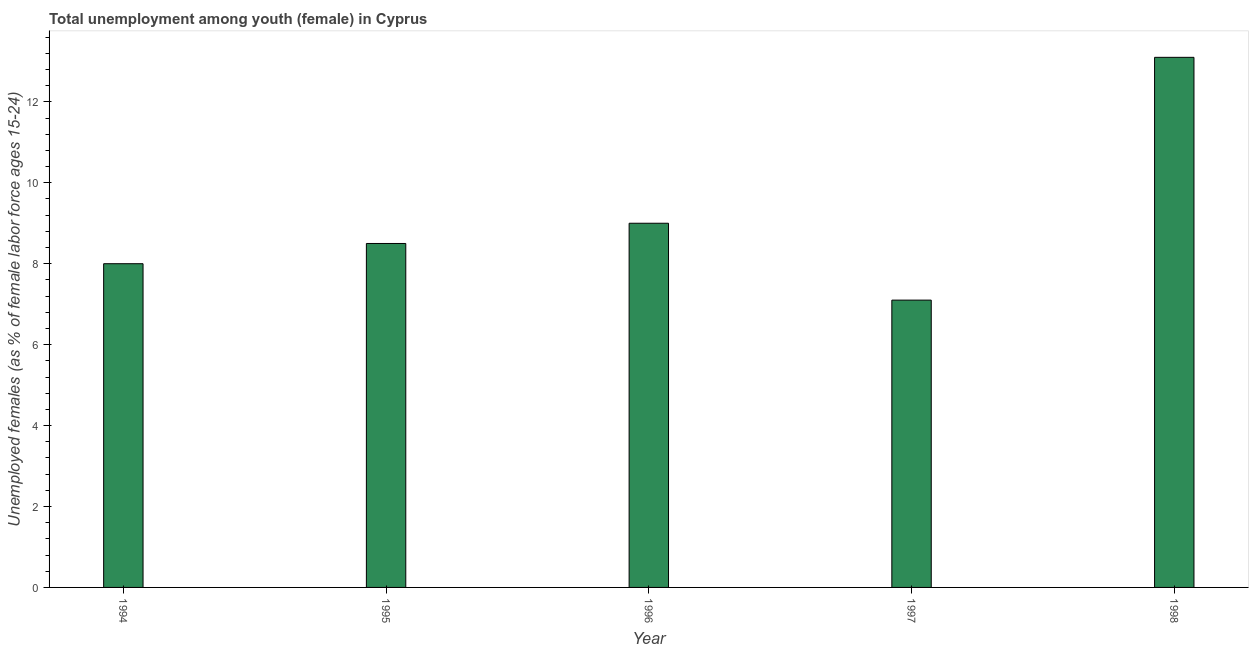Does the graph contain grids?
Offer a terse response. No. What is the title of the graph?
Your answer should be very brief. Total unemployment among youth (female) in Cyprus. What is the label or title of the Y-axis?
Provide a succinct answer. Unemployed females (as % of female labor force ages 15-24). What is the unemployed female youth population in 1997?
Keep it short and to the point. 7.1. Across all years, what is the maximum unemployed female youth population?
Your response must be concise. 13.1. Across all years, what is the minimum unemployed female youth population?
Your answer should be compact. 7.1. In which year was the unemployed female youth population maximum?
Your answer should be very brief. 1998. In which year was the unemployed female youth population minimum?
Your response must be concise. 1997. What is the sum of the unemployed female youth population?
Offer a very short reply. 45.7. What is the average unemployed female youth population per year?
Offer a very short reply. 9.14. What is the median unemployed female youth population?
Provide a succinct answer. 8.5. What is the ratio of the unemployed female youth population in 1994 to that in 1995?
Your answer should be compact. 0.94. Is the unemployed female youth population in 1994 less than that in 1997?
Your answer should be very brief. No. Is the difference between the unemployed female youth population in 1995 and 1996 greater than the difference between any two years?
Provide a succinct answer. No. What is the difference between the highest and the second highest unemployed female youth population?
Provide a short and direct response. 4.1. Is the sum of the unemployed female youth population in 1996 and 1997 greater than the maximum unemployed female youth population across all years?
Offer a terse response. Yes. What is the difference between the highest and the lowest unemployed female youth population?
Provide a succinct answer. 6. How many years are there in the graph?
Make the answer very short. 5. What is the Unemployed females (as % of female labor force ages 15-24) of 1994?
Keep it short and to the point. 8. What is the Unemployed females (as % of female labor force ages 15-24) in 1996?
Provide a short and direct response. 9. What is the Unemployed females (as % of female labor force ages 15-24) in 1997?
Give a very brief answer. 7.1. What is the Unemployed females (as % of female labor force ages 15-24) in 1998?
Give a very brief answer. 13.1. What is the difference between the Unemployed females (as % of female labor force ages 15-24) in 1994 and 1996?
Provide a succinct answer. -1. What is the difference between the Unemployed females (as % of female labor force ages 15-24) in 1994 and 1997?
Provide a succinct answer. 0.9. What is the difference between the Unemployed females (as % of female labor force ages 15-24) in 1994 and 1998?
Provide a short and direct response. -5.1. What is the difference between the Unemployed females (as % of female labor force ages 15-24) in 1995 and 1997?
Give a very brief answer. 1.4. What is the difference between the Unemployed females (as % of female labor force ages 15-24) in 1997 and 1998?
Your answer should be very brief. -6. What is the ratio of the Unemployed females (as % of female labor force ages 15-24) in 1994 to that in 1995?
Your response must be concise. 0.94. What is the ratio of the Unemployed females (as % of female labor force ages 15-24) in 1994 to that in 1996?
Provide a short and direct response. 0.89. What is the ratio of the Unemployed females (as % of female labor force ages 15-24) in 1994 to that in 1997?
Your response must be concise. 1.13. What is the ratio of the Unemployed females (as % of female labor force ages 15-24) in 1994 to that in 1998?
Provide a succinct answer. 0.61. What is the ratio of the Unemployed females (as % of female labor force ages 15-24) in 1995 to that in 1996?
Your answer should be very brief. 0.94. What is the ratio of the Unemployed females (as % of female labor force ages 15-24) in 1995 to that in 1997?
Provide a succinct answer. 1.2. What is the ratio of the Unemployed females (as % of female labor force ages 15-24) in 1995 to that in 1998?
Your answer should be compact. 0.65. What is the ratio of the Unemployed females (as % of female labor force ages 15-24) in 1996 to that in 1997?
Keep it short and to the point. 1.27. What is the ratio of the Unemployed females (as % of female labor force ages 15-24) in 1996 to that in 1998?
Provide a succinct answer. 0.69. What is the ratio of the Unemployed females (as % of female labor force ages 15-24) in 1997 to that in 1998?
Give a very brief answer. 0.54. 